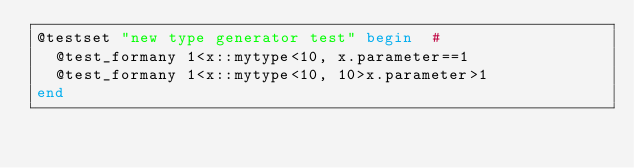<code> <loc_0><loc_0><loc_500><loc_500><_Julia_>@testset "new type generator test" begin  #
	@test_formany 1<x::mytype<10, x.parameter==1
	@test_formany 1<x::mytype<10, 10>x.parameter>1
end</code> 